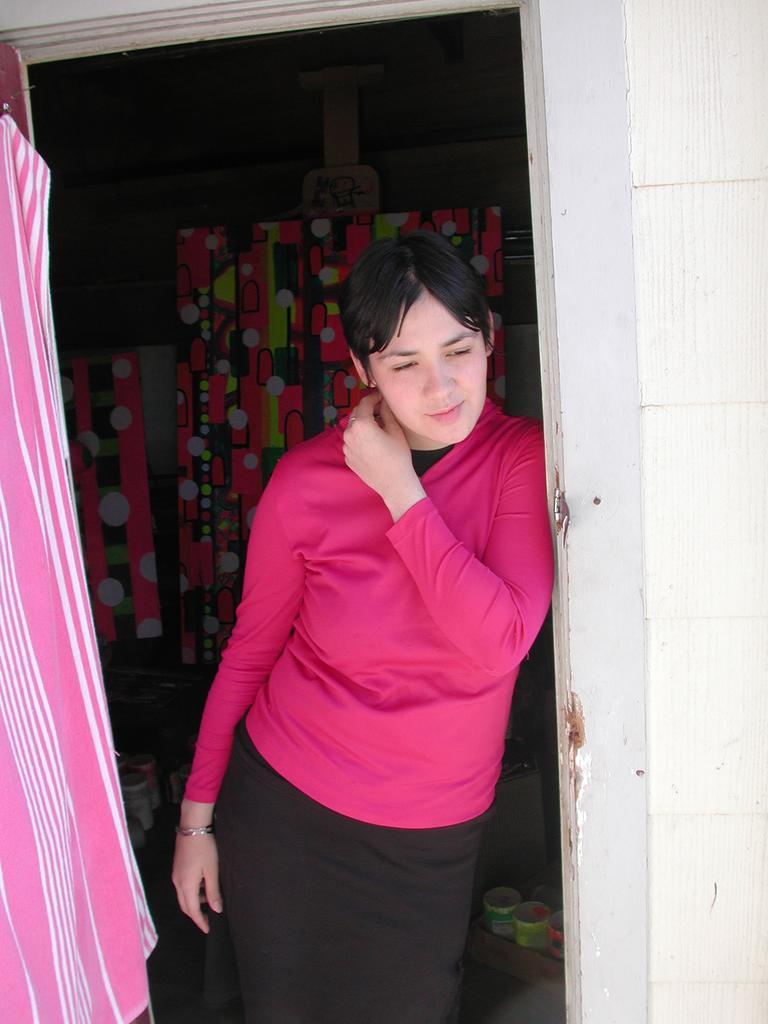Please provide a concise description of this image. In this picture we can see s woman, she wore a pink color T-shirt, behind to her we can see few bottles. 